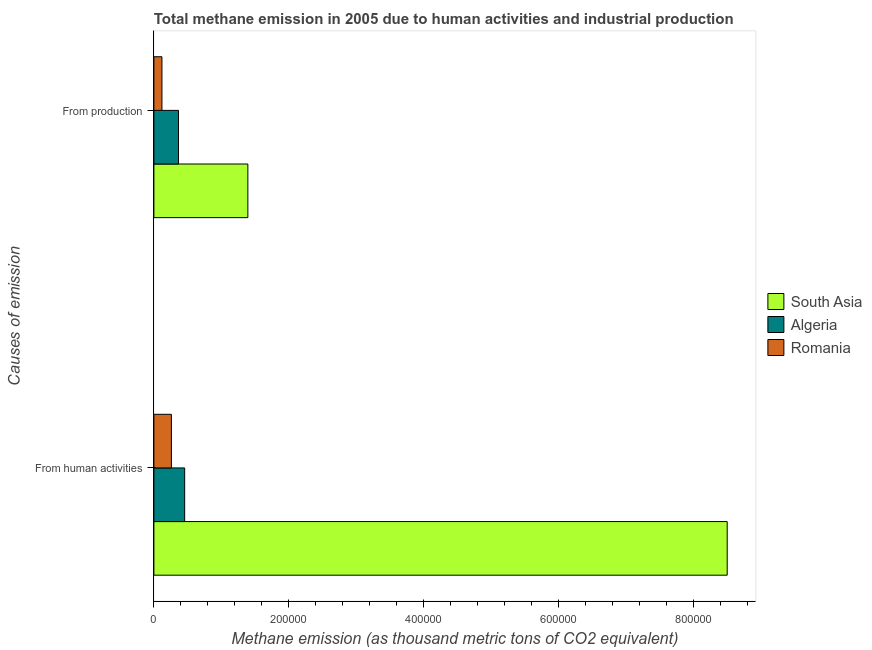How many different coloured bars are there?
Make the answer very short. 3. How many groups of bars are there?
Give a very brief answer. 2. Are the number of bars on each tick of the Y-axis equal?
Your answer should be compact. Yes. How many bars are there on the 2nd tick from the bottom?
Offer a very short reply. 3. What is the label of the 2nd group of bars from the top?
Give a very brief answer. From human activities. What is the amount of emissions generated from industries in Algeria?
Your answer should be very brief. 3.65e+04. Across all countries, what is the maximum amount of emissions generated from industries?
Offer a very short reply. 1.39e+05. Across all countries, what is the minimum amount of emissions generated from industries?
Your answer should be compact. 1.19e+04. In which country was the amount of emissions from human activities maximum?
Offer a terse response. South Asia. In which country was the amount of emissions generated from industries minimum?
Offer a very short reply. Romania. What is the total amount of emissions generated from industries in the graph?
Offer a terse response. 1.88e+05. What is the difference between the amount of emissions from human activities in Algeria and that in South Asia?
Your response must be concise. -8.04e+05. What is the difference between the amount of emissions from human activities in South Asia and the amount of emissions generated from industries in Romania?
Offer a very short reply. 8.38e+05. What is the average amount of emissions generated from industries per country?
Ensure brevity in your answer.  6.26e+04. What is the difference between the amount of emissions generated from industries and amount of emissions from human activities in South Asia?
Provide a succinct answer. -7.11e+05. In how many countries, is the amount of emissions generated from industries greater than 720000 thousand metric tons?
Your response must be concise. 0. What is the ratio of the amount of emissions from human activities in Algeria to that in South Asia?
Offer a very short reply. 0.05. What does the 1st bar from the top in From human activities represents?
Keep it short and to the point. Romania. How many bars are there?
Provide a short and direct response. 6. How many countries are there in the graph?
Give a very brief answer. 3. What is the difference between two consecutive major ticks on the X-axis?
Provide a short and direct response. 2.00e+05. Does the graph contain any zero values?
Your answer should be compact. No. Does the graph contain grids?
Ensure brevity in your answer.  No. Where does the legend appear in the graph?
Provide a short and direct response. Center right. How many legend labels are there?
Your answer should be compact. 3. What is the title of the graph?
Provide a short and direct response. Total methane emission in 2005 due to human activities and industrial production. What is the label or title of the X-axis?
Offer a very short reply. Methane emission (as thousand metric tons of CO2 equivalent). What is the label or title of the Y-axis?
Ensure brevity in your answer.  Causes of emission. What is the Methane emission (as thousand metric tons of CO2 equivalent) in South Asia in From human activities?
Offer a terse response. 8.50e+05. What is the Methane emission (as thousand metric tons of CO2 equivalent) in Algeria in From human activities?
Offer a very short reply. 4.56e+04. What is the Methane emission (as thousand metric tons of CO2 equivalent) of Romania in From human activities?
Offer a very short reply. 2.60e+04. What is the Methane emission (as thousand metric tons of CO2 equivalent) in South Asia in From production?
Your answer should be compact. 1.39e+05. What is the Methane emission (as thousand metric tons of CO2 equivalent) of Algeria in From production?
Your answer should be compact. 3.65e+04. What is the Methane emission (as thousand metric tons of CO2 equivalent) of Romania in From production?
Your response must be concise. 1.19e+04. Across all Causes of emission, what is the maximum Methane emission (as thousand metric tons of CO2 equivalent) in South Asia?
Your answer should be compact. 8.50e+05. Across all Causes of emission, what is the maximum Methane emission (as thousand metric tons of CO2 equivalent) of Algeria?
Your response must be concise. 4.56e+04. Across all Causes of emission, what is the maximum Methane emission (as thousand metric tons of CO2 equivalent) of Romania?
Give a very brief answer. 2.60e+04. Across all Causes of emission, what is the minimum Methane emission (as thousand metric tons of CO2 equivalent) in South Asia?
Ensure brevity in your answer.  1.39e+05. Across all Causes of emission, what is the minimum Methane emission (as thousand metric tons of CO2 equivalent) in Algeria?
Offer a very short reply. 3.65e+04. Across all Causes of emission, what is the minimum Methane emission (as thousand metric tons of CO2 equivalent) of Romania?
Provide a short and direct response. 1.19e+04. What is the total Methane emission (as thousand metric tons of CO2 equivalent) in South Asia in the graph?
Your answer should be very brief. 9.89e+05. What is the total Methane emission (as thousand metric tons of CO2 equivalent) in Algeria in the graph?
Make the answer very short. 8.21e+04. What is the total Methane emission (as thousand metric tons of CO2 equivalent) in Romania in the graph?
Your response must be concise. 3.79e+04. What is the difference between the Methane emission (as thousand metric tons of CO2 equivalent) of South Asia in From human activities and that in From production?
Ensure brevity in your answer.  7.11e+05. What is the difference between the Methane emission (as thousand metric tons of CO2 equivalent) in Algeria in From human activities and that in From production?
Keep it short and to the point. 9127.1. What is the difference between the Methane emission (as thousand metric tons of CO2 equivalent) in Romania in From human activities and that in From production?
Offer a terse response. 1.40e+04. What is the difference between the Methane emission (as thousand metric tons of CO2 equivalent) in South Asia in From human activities and the Methane emission (as thousand metric tons of CO2 equivalent) in Algeria in From production?
Give a very brief answer. 8.13e+05. What is the difference between the Methane emission (as thousand metric tons of CO2 equivalent) in South Asia in From human activities and the Methane emission (as thousand metric tons of CO2 equivalent) in Romania in From production?
Your answer should be compact. 8.38e+05. What is the difference between the Methane emission (as thousand metric tons of CO2 equivalent) of Algeria in From human activities and the Methane emission (as thousand metric tons of CO2 equivalent) of Romania in From production?
Your response must be concise. 3.37e+04. What is the average Methane emission (as thousand metric tons of CO2 equivalent) in South Asia per Causes of emission?
Keep it short and to the point. 4.95e+05. What is the average Methane emission (as thousand metric tons of CO2 equivalent) in Algeria per Causes of emission?
Ensure brevity in your answer.  4.10e+04. What is the average Methane emission (as thousand metric tons of CO2 equivalent) in Romania per Causes of emission?
Provide a short and direct response. 1.89e+04. What is the difference between the Methane emission (as thousand metric tons of CO2 equivalent) in South Asia and Methane emission (as thousand metric tons of CO2 equivalent) in Algeria in From human activities?
Make the answer very short. 8.04e+05. What is the difference between the Methane emission (as thousand metric tons of CO2 equivalent) of South Asia and Methane emission (as thousand metric tons of CO2 equivalent) of Romania in From human activities?
Give a very brief answer. 8.24e+05. What is the difference between the Methane emission (as thousand metric tons of CO2 equivalent) of Algeria and Methane emission (as thousand metric tons of CO2 equivalent) of Romania in From human activities?
Keep it short and to the point. 1.97e+04. What is the difference between the Methane emission (as thousand metric tons of CO2 equivalent) of South Asia and Methane emission (as thousand metric tons of CO2 equivalent) of Algeria in From production?
Keep it short and to the point. 1.03e+05. What is the difference between the Methane emission (as thousand metric tons of CO2 equivalent) in South Asia and Methane emission (as thousand metric tons of CO2 equivalent) in Romania in From production?
Your answer should be compact. 1.27e+05. What is the difference between the Methane emission (as thousand metric tons of CO2 equivalent) in Algeria and Methane emission (as thousand metric tons of CO2 equivalent) in Romania in From production?
Offer a very short reply. 2.45e+04. What is the ratio of the Methane emission (as thousand metric tons of CO2 equivalent) in South Asia in From human activities to that in From production?
Your answer should be compact. 6.1. What is the ratio of the Methane emission (as thousand metric tons of CO2 equivalent) in Algeria in From human activities to that in From production?
Offer a very short reply. 1.25. What is the ratio of the Methane emission (as thousand metric tons of CO2 equivalent) of Romania in From human activities to that in From production?
Provide a short and direct response. 2.17. What is the difference between the highest and the second highest Methane emission (as thousand metric tons of CO2 equivalent) in South Asia?
Your response must be concise. 7.11e+05. What is the difference between the highest and the second highest Methane emission (as thousand metric tons of CO2 equivalent) of Algeria?
Your answer should be very brief. 9127.1. What is the difference between the highest and the second highest Methane emission (as thousand metric tons of CO2 equivalent) in Romania?
Your answer should be very brief. 1.40e+04. What is the difference between the highest and the lowest Methane emission (as thousand metric tons of CO2 equivalent) of South Asia?
Keep it short and to the point. 7.11e+05. What is the difference between the highest and the lowest Methane emission (as thousand metric tons of CO2 equivalent) of Algeria?
Offer a very short reply. 9127.1. What is the difference between the highest and the lowest Methane emission (as thousand metric tons of CO2 equivalent) of Romania?
Keep it short and to the point. 1.40e+04. 